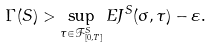Convert formula to latex. <formula><loc_0><loc_0><loc_500><loc_500>\Gamma ( S ) > \sup _ { \tau \in \mathcal { F } ^ { S } _ { [ 0 , T ] } } E J ^ { S } ( \sigma , \tau ) - \varepsilon .</formula> 